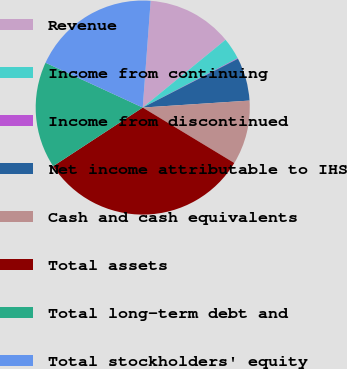Convert chart to OTSL. <chart><loc_0><loc_0><loc_500><loc_500><pie_chart><fcel>Revenue<fcel>Income from continuing<fcel>Income from discontinued<fcel>Net income attributable to IHS<fcel>Cash and cash equivalents<fcel>Total assets<fcel>Total long-term debt and<fcel>Total stockholders' equity<nl><fcel>12.9%<fcel>3.29%<fcel>0.09%<fcel>6.5%<fcel>9.7%<fcel>32.11%<fcel>16.1%<fcel>19.3%<nl></chart> 